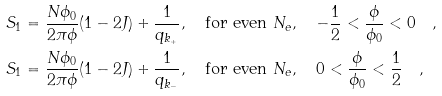Convert formula to latex. <formula><loc_0><loc_0><loc_500><loc_500>S _ { 1 } & = \frac { N \phi _ { 0 } } { 2 \pi \phi } ( 1 - 2 J ) + \frac { 1 } { q _ { k _ { + } } } , \quad \text {for even } N _ { e } , \quad - \frac { 1 } { 2 } < \frac { \phi } { \phi _ { 0 } } < 0 \quad , \\ S _ { 1 } & = \frac { N \phi _ { 0 } } { 2 \pi \phi } ( 1 - 2 J ) + \frac { 1 } { q _ { k _ { - } } } , \quad \text {for even } N _ { e } , \quad 0 < \frac { \phi } { \phi _ { 0 } } < \frac { 1 } { 2 } \quad ,</formula> 